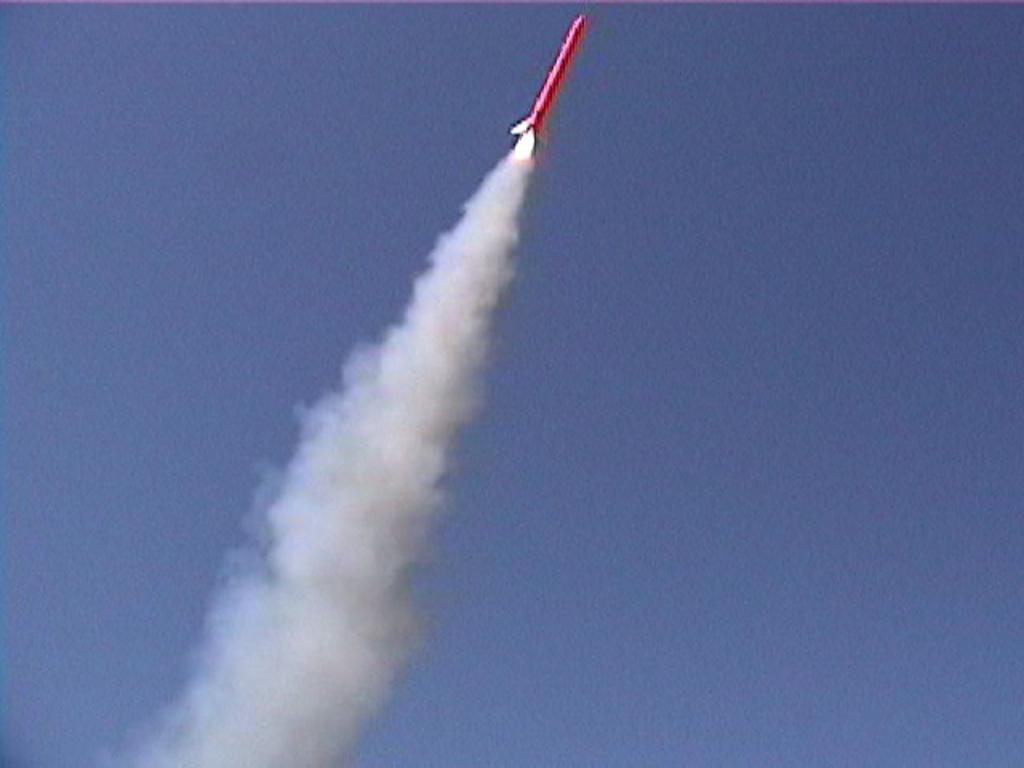What is the main subject in the sky in the image? There is a rocket in the sky in the image. What can be seen at the bottom of the image? There is smoke at the bottom of the image. What is visible at the top of the image? The sky is visible at the top of the image. What type of cabbage is being used as a board in the image? There is no cabbage or board present in the image. 